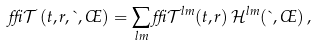<formula> <loc_0><loc_0><loc_500><loc_500>\delta \mathcal { T } \left ( t , r , \theta , \phi \right ) = \sum _ { l m } \delta \mathcal { T } ^ { l m } ( t , r ) \, \mathcal { H } ^ { l m } ( \theta , \phi ) \, ,</formula> 